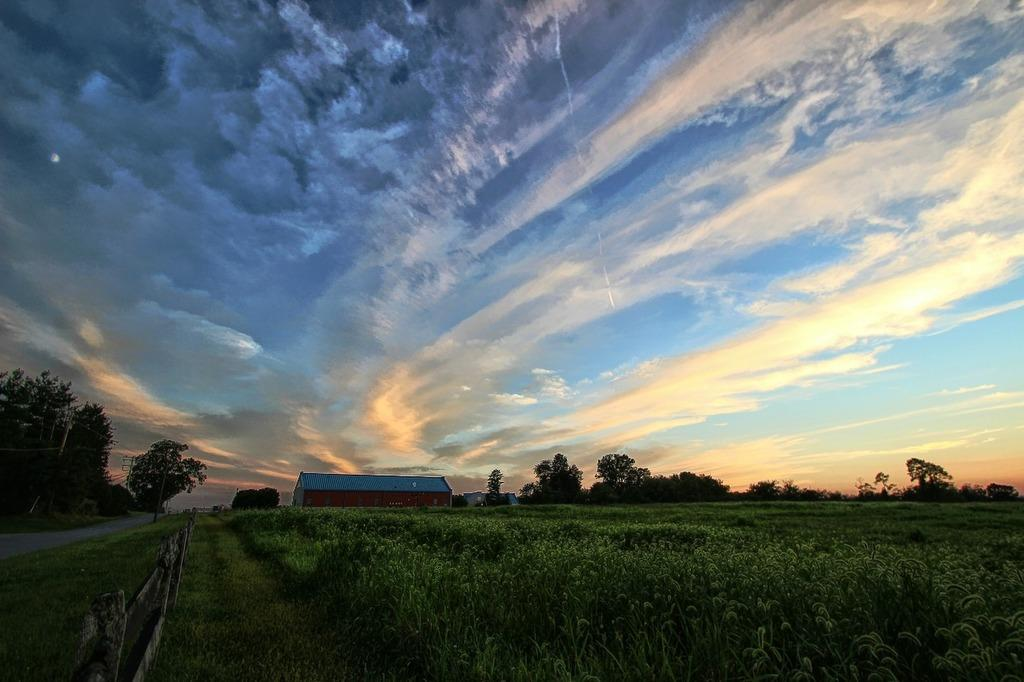What type of vegetation is present in the image? There is green grass in the image. Where is the wooden fence located in the image? The wooden fence is in the left corner of the image. What can be seen in the background of the image? There is a house and trees in the background of the image. What is visible in the sky in the image? The sky is visible in the image and appears to be slightly cloudy. What memory is being discussed in the image? There is no memory being discussed in the image; it is a visual representation of a scene with green grass, a wooden fence, a house, trees, and a slightly cloudy sky. What type of cloud is present in the image? There is no specific type of cloud mentioned or depicted in the image; the sky is simply described as slightly cloudy. 